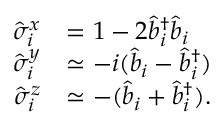Convert formula to latex. <formula><loc_0><loc_0><loc_500><loc_500>\begin{array} { r l } { \hat { \sigma } _ { i } ^ { x } } & { = 1 - 2 \hat { b } _ { i } ^ { \dagger } \hat { b } _ { i } } \\ { \hat { \sigma } _ { i } ^ { y } } & { \simeq - i ( \hat { b } _ { i } - \hat { b } _ { i } ^ { \dagger } ) } \\ { \hat { \sigma } _ { i } ^ { z } } & { \simeq - ( \hat { b } _ { i } + \hat { b } _ { i } ^ { \dagger } ) . } \end{array}</formula> 